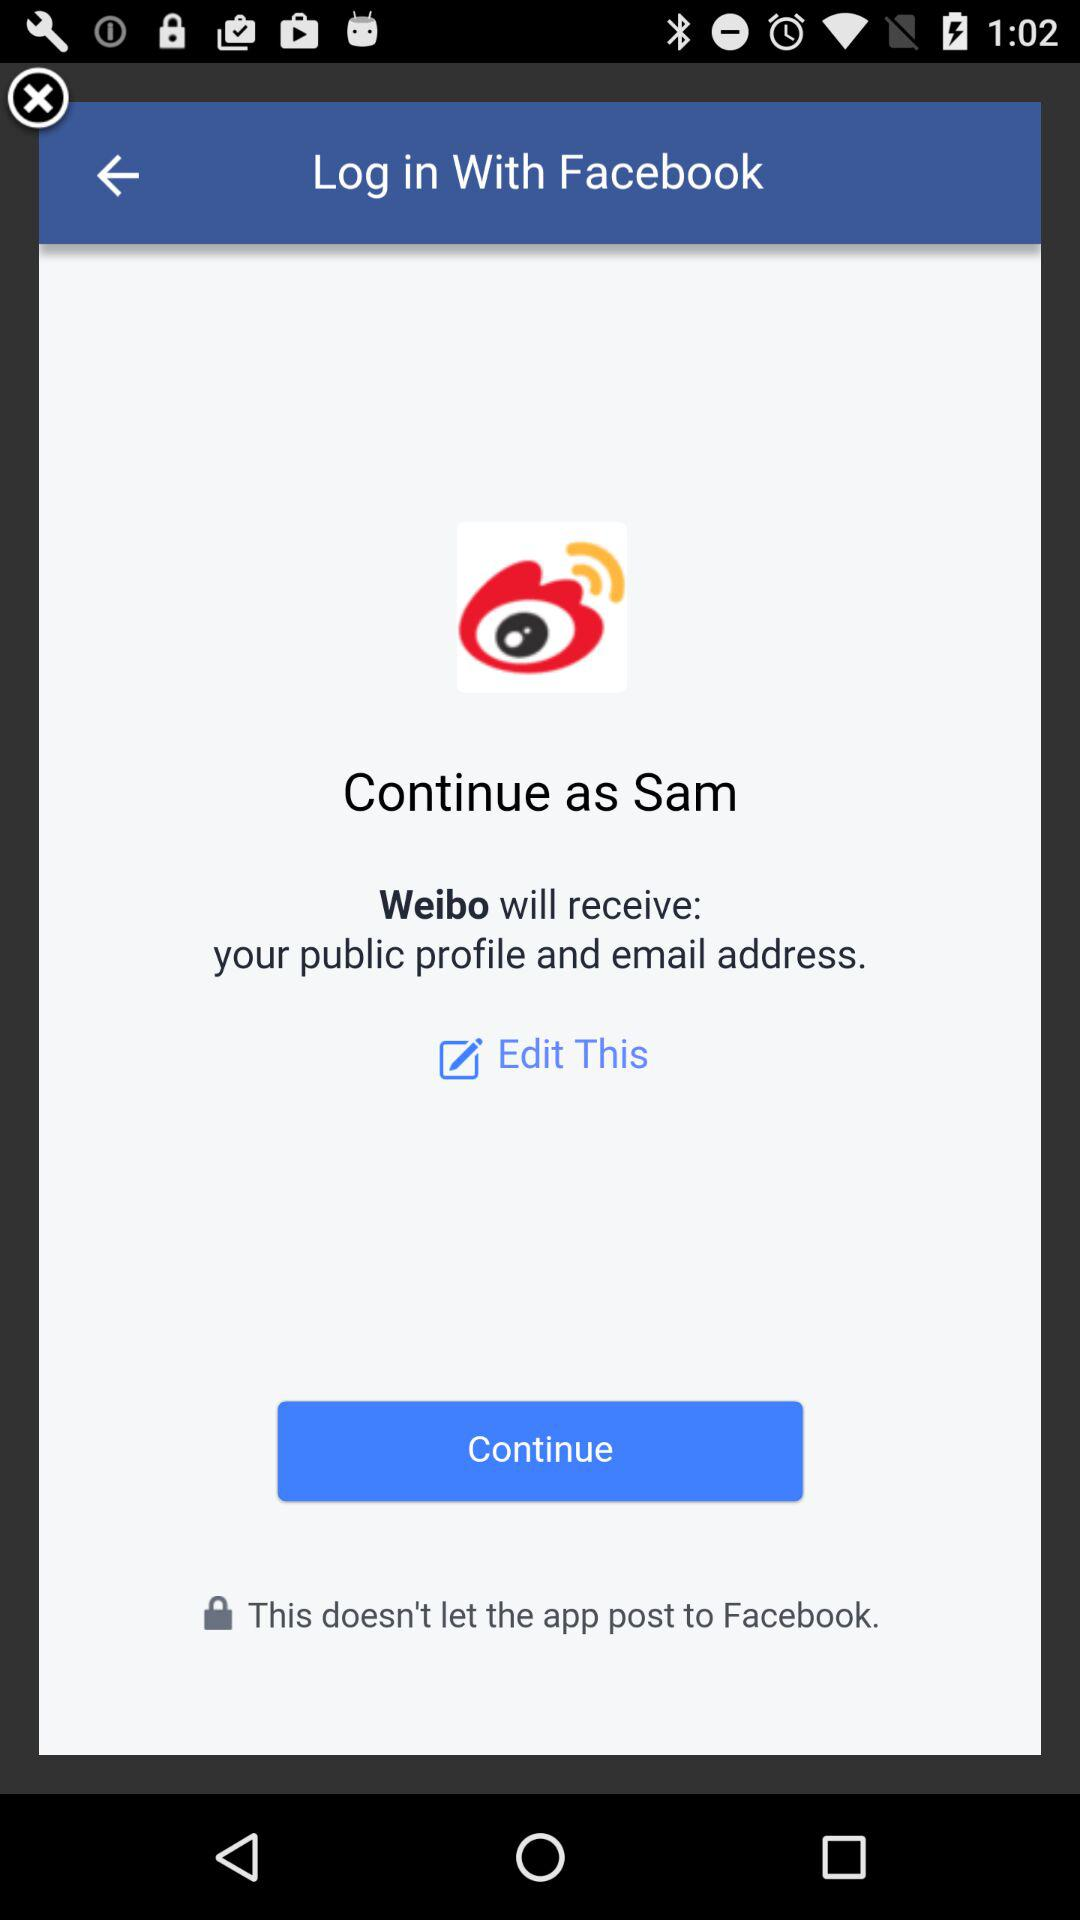What application is asking for permission? The application name is "Facebook". 